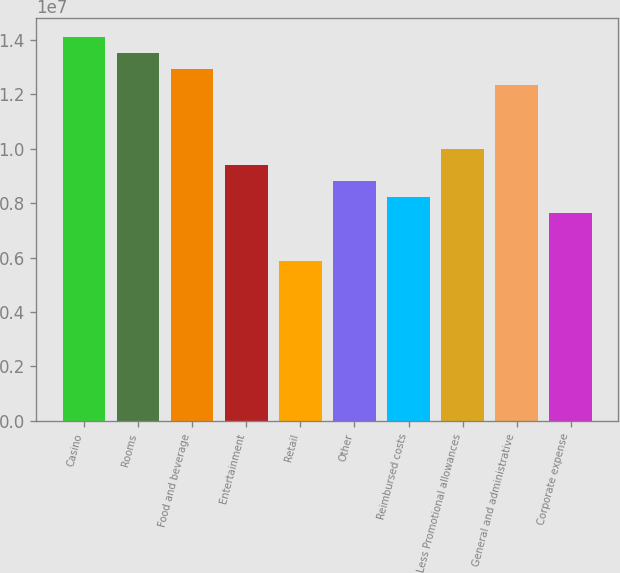Convert chart. <chart><loc_0><loc_0><loc_500><loc_500><bar_chart><fcel>Casino<fcel>Rooms<fcel>Food and beverage<fcel>Entertainment<fcel>Retail<fcel>Other<fcel>Reimbursed costs<fcel>Less Promotional allowances<fcel>General and administrative<fcel>Corporate expense<nl><fcel>1.41019e+07<fcel>1.35143e+07<fcel>1.29267e+07<fcel>9.40125e+06<fcel>5.87578e+06<fcel>8.81367e+06<fcel>8.22609e+06<fcel>9.98883e+06<fcel>1.23391e+07<fcel>7.63852e+06<nl></chart> 